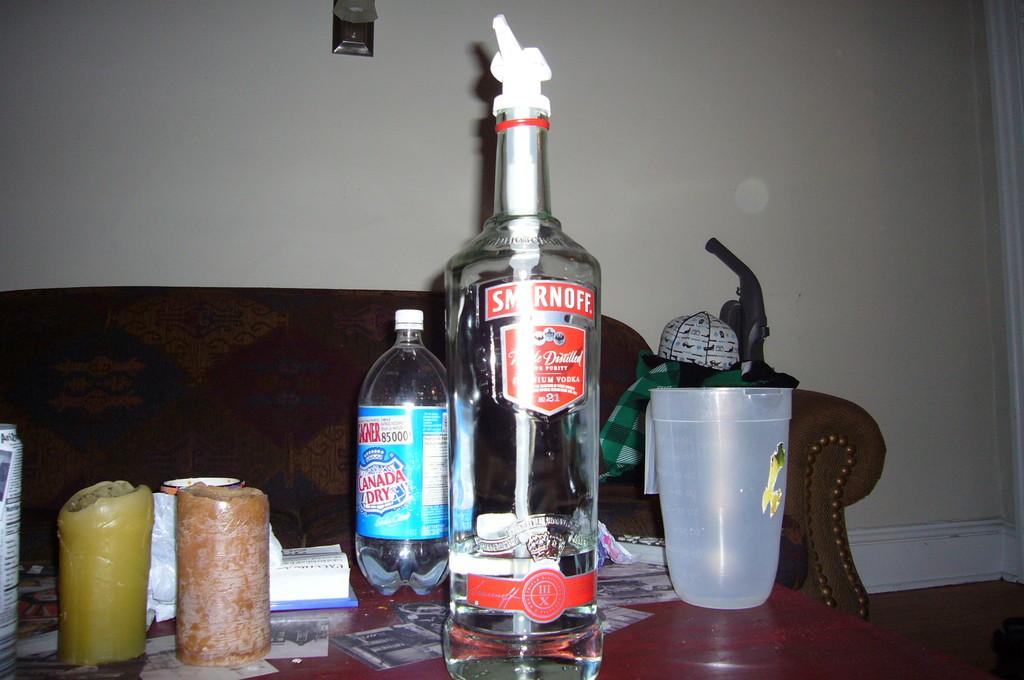What kind of chasers?
Give a very brief answer. Canada dry. What is the brand on the bottle?
Ensure brevity in your answer.  Smirnoff. 